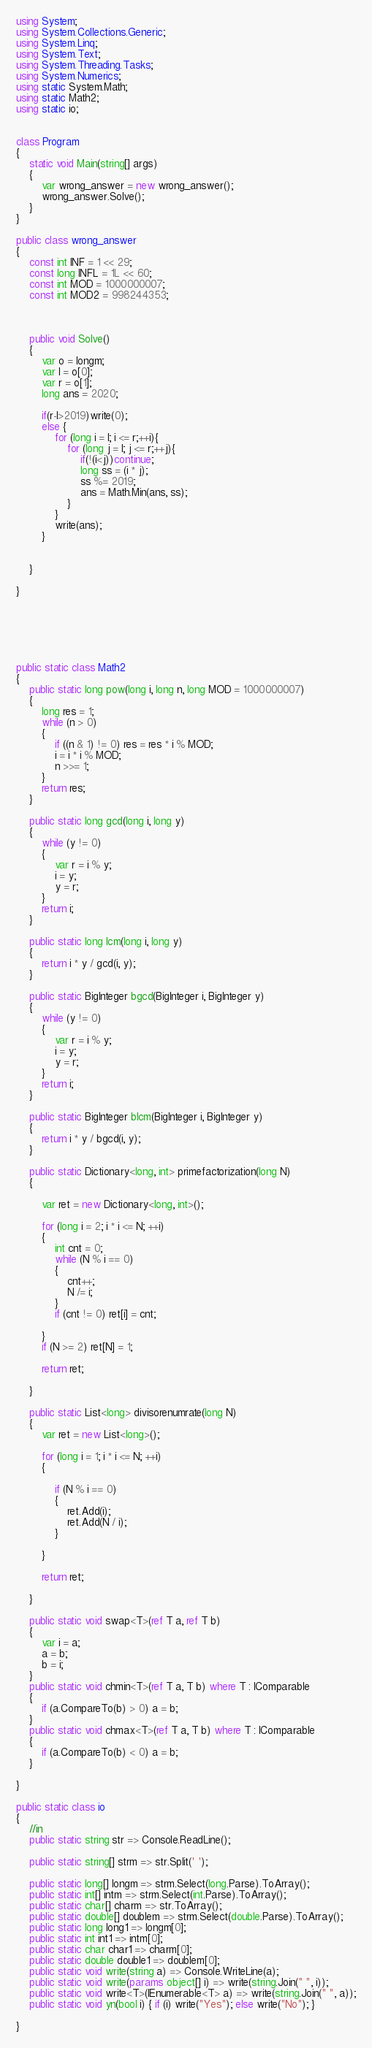Convert code to text. <code><loc_0><loc_0><loc_500><loc_500><_C#_>using System;
using System.Collections.Generic;
using System.Linq;
using System.Text;
using System.Threading.Tasks;
using System.Numerics;
using static System.Math;
using static Math2;
using static io;


class Program
{
    static void Main(string[] args)
    {
        var wrong_answer = new wrong_answer();
        wrong_answer.Solve();
    }
}

public class wrong_answer
{
    const int INF = 1 << 29;
    const long INFL = 1L << 60;
    const int MOD = 1000000007;
    const int MOD2 = 998244353;



    public void Solve()
    {
        var o = longm;
        var l = o[0];
        var r = o[1];
        long ans = 2020;

        if(r-l>2019)write(0);
        else {
            for (long i = l; i <= r;++i){
                for (long j = l; j <= r;++j){
                    if(!(i<j))continue;
                    long ss = (i * j);
                    ss %= 2019;
                    ans = Math.Min(ans, ss);
                }
            }
            write(ans);
        }


    }

}






public static class Math2
{
    public static long pow(long i, long n, long MOD = 1000000007)
    {
        long res = 1;
        while (n > 0)
        {
            if ((n & 1) != 0) res = res * i % MOD;
            i = i * i % MOD;
            n >>= 1;
        }
        return res;
    }

    public static long gcd(long i, long y)
    {
        while (y != 0)
        {
            var r = i % y;
            i = y;
            y = r;
        }
        return i;
    }

    public static long lcm(long i, long y)
    {
        return i * y / gcd(i, y);
    }

    public static BigInteger bgcd(BigInteger i, BigInteger y)
    {
        while (y != 0)
        {
            var r = i % y;
            i = y;
            y = r;
        }
        return i;
    }

    public static BigInteger blcm(BigInteger i, BigInteger y)
    {
        return i * y / bgcd(i, y);
    }

    public static Dictionary<long, int> primefactorization(long N)
    {

        var ret = new Dictionary<long, int>();

        for (long i = 2; i * i <= N; ++i)
        {
            int cnt = 0;
            while (N % i == 0)
            {
                cnt++;
                N /= i;
            }
            if (cnt != 0) ret[i] = cnt;

        }
        if (N >= 2) ret[N] = 1;

        return ret;

    }

    public static List<long> divisorenumrate(long N)
    {
        var ret = new List<long>();

        for (long i = 1; i * i <= N; ++i)
        {

            if (N % i == 0)
            {
                ret.Add(i);
                ret.Add(N / i);
            }

        }

        return ret;

    }

    public static void swap<T>(ref T a, ref T b)
    {
        var i = a;
        a = b;
        b = i;
    }
    public static void chmin<T>(ref T a, T b) where T : IComparable
    {
        if (a.CompareTo(b) > 0) a = b;
    }
    public static void chmax<T>(ref T a, T b) where T : IComparable
    {
        if (a.CompareTo(b) < 0) a = b;
    }

}

public static class io
{
    //in
    public static string str => Console.ReadLine();

    public static string[] strm => str.Split(' ');

    public static long[] longm => strm.Select(long.Parse).ToArray();
    public static int[] intm => strm.Select(int.Parse).ToArray();
    public static char[] charm => str.ToArray();
    public static double[] doublem => strm.Select(double.Parse).ToArray();
    public static long long1 => longm[0];
    public static int int1 => intm[0];
    public static char char1 => charm[0];
    public static double double1 => doublem[0];
    public static void write(string a) => Console.WriteLine(a);
    public static void write(params object[] i) => write(string.Join(" ", i));
    public static void write<T>(IEnumerable<T> a) => write(string.Join(" ", a));
    public static void yn(bool i) { if (i) write("Yes"); else write("No"); }

}
</code> 